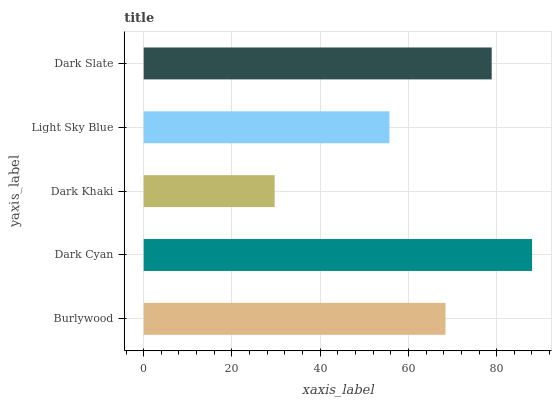Is Dark Khaki the minimum?
Answer yes or no. Yes. Is Dark Cyan the maximum?
Answer yes or no. Yes. Is Dark Cyan the minimum?
Answer yes or no. No. Is Dark Khaki the maximum?
Answer yes or no. No. Is Dark Cyan greater than Dark Khaki?
Answer yes or no. Yes. Is Dark Khaki less than Dark Cyan?
Answer yes or no. Yes. Is Dark Khaki greater than Dark Cyan?
Answer yes or no. No. Is Dark Cyan less than Dark Khaki?
Answer yes or no. No. Is Burlywood the high median?
Answer yes or no. Yes. Is Burlywood the low median?
Answer yes or no. Yes. Is Dark Slate the high median?
Answer yes or no. No. Is Dark Cyan the low median?
Answer yes or no. No. 